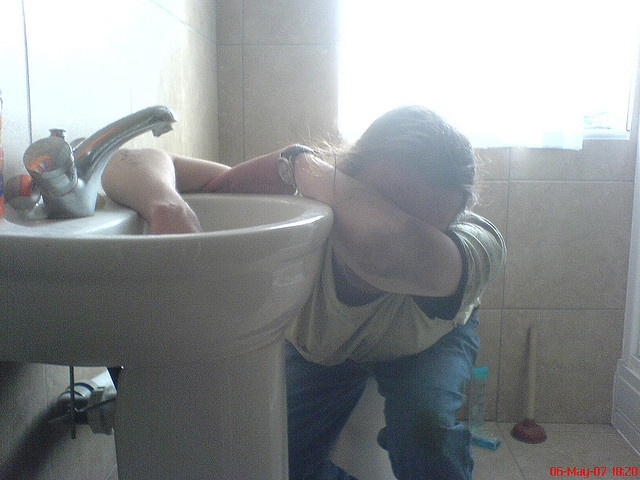Describe the objects in this image and their specific colors. I can see sink in white, gray, darkgray, purple, and black tones, people in white, gray, darkgray, and black tones, and toilet in white, gray, purple, and black tones in this image. 